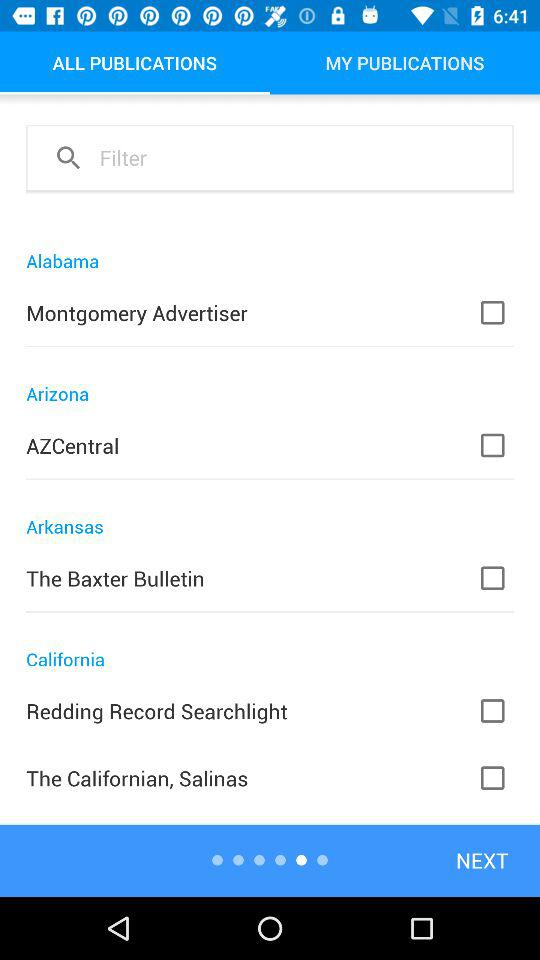How many publications are from California?
Answer the question using a single word or phrase. 2 